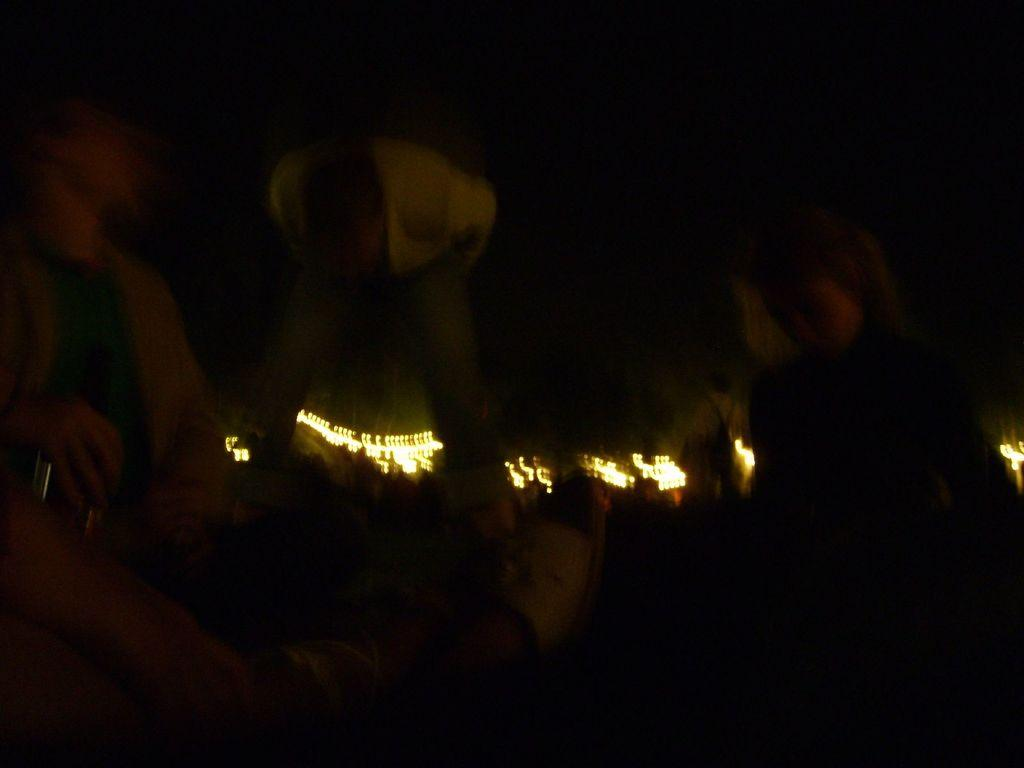How many people are in the image? There is a group of people in the image, but the exact number cannot be determined from the provided facts. What can be seen in addition to the people in the image? Lights are visible in the image. What is the general appearance of the background in the image? The background of the image appears to be dark. How many pears are being held by the crow in the image? There is no crow or pear present in the image. 